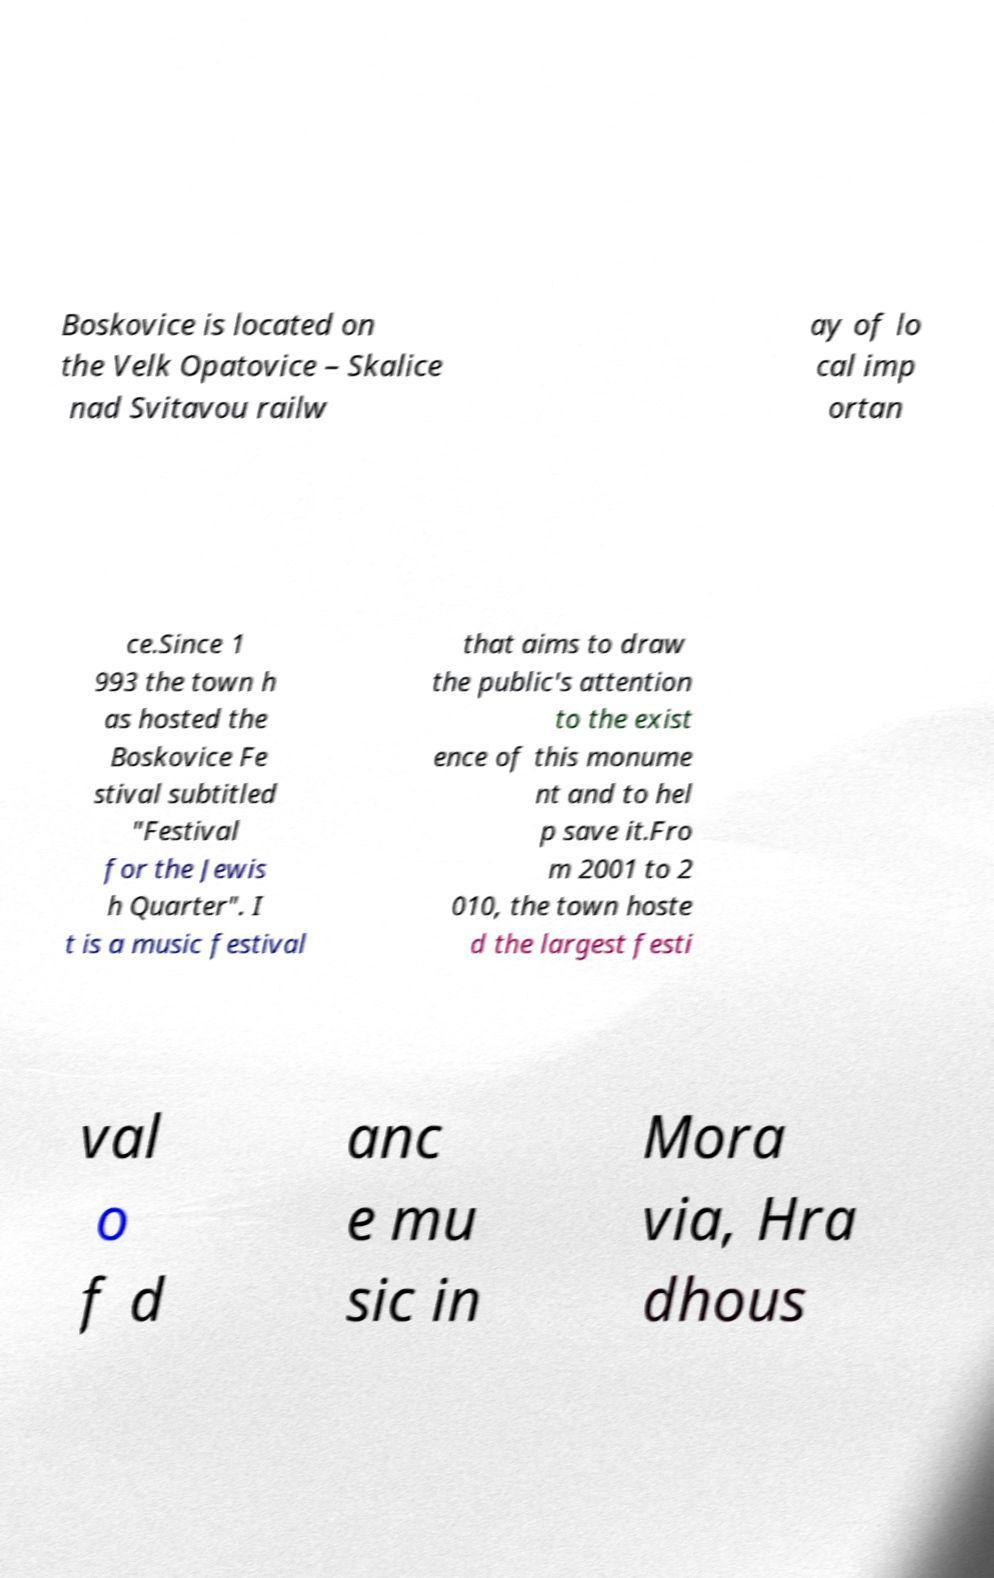Could you assist in decoding the text presented in this image and type it out clearly? Boskovice is located on the Velk Opatovice – Skalice nad Svitavou railw ay of lo cal imp ortan ce.Since 1 993 the town h as hosted the Boskovice Fe stival subtitled "Festival for the Jewis h Quarter". I t is a music festival that aims to draw the public's attention to the exist ence of this monume nt and to hel p save it.Fro m 2001 to 2 010, the town hoste d the largest festi val o f d anc e mu sic in Mora via, Hra dhous 